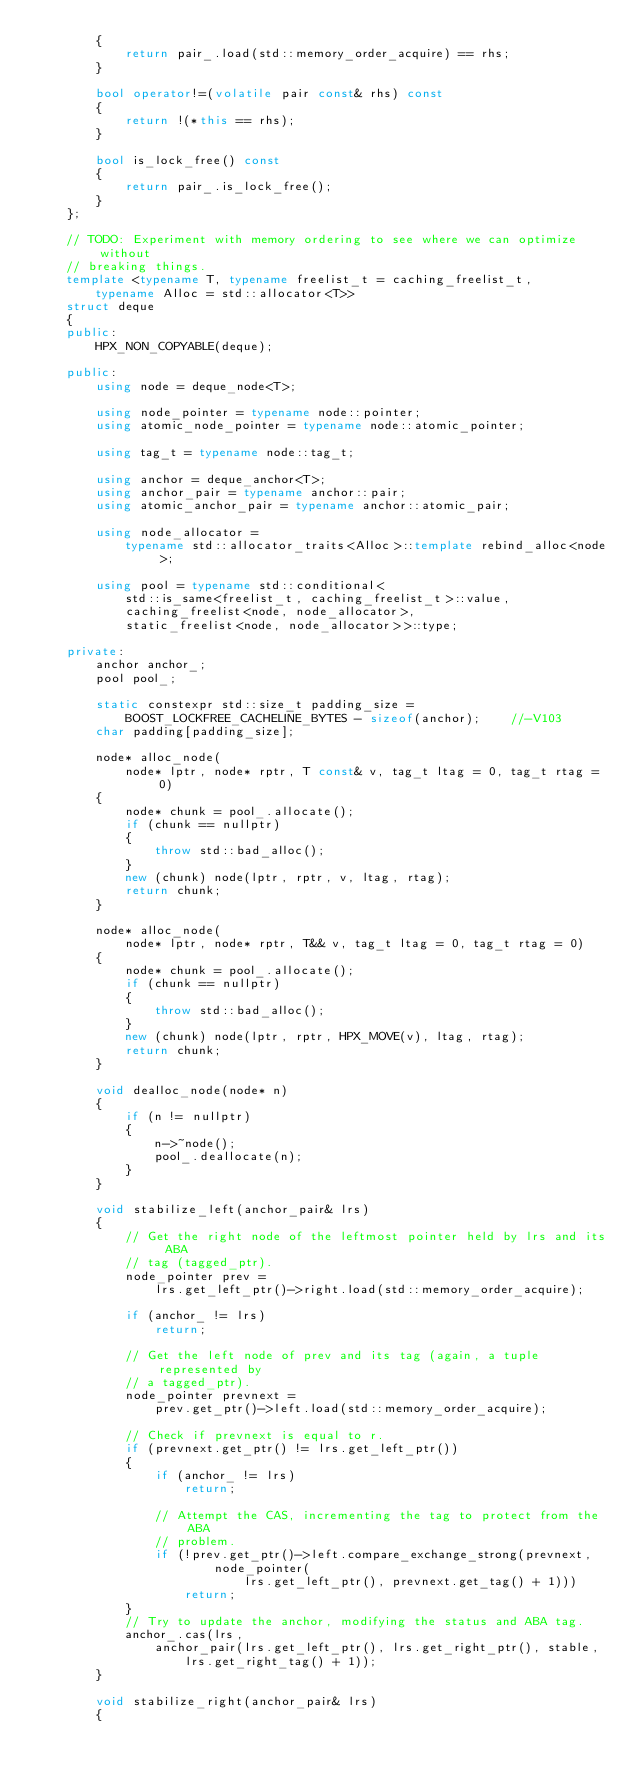Convert code to text. <code><loc_0><loc_0><loc_500><loc_500><_C++_>        {
            return pair_.load(std::memory_order_acquire) == rhs;
        }

        bool operator!=(volatile pair const& rhs) const
        {
            return !(*this == rhs);
        }

        bool is_lock_free() const
        {
            return pair_.is_lock_free();
        }
    };

    // TODO: Experiment with memory ordering to see where we can optimize without
    // breaking things.
    template <typename T, typename freelist_t = caching_freelist_t,
        typename Alloc = std::allocator<T>>
    struct deque
    {
    public:
        HPX_NON_COPYABLE(deque);

    public:
        using node = deque_node<T>;

        using node_pointer = typename node::pointer;
        using atomic_node_pointer = typename node::atomic_pointer;

        using tag_t = typename node::tag_t;

        using anchor = deque_anchor<T>;
        using anchor_pair = typename anchor::pair;
        using atomic_anchor_pair = typename anchor::atomic_pair;

        using node_allocator =
            typename std::allocator_traits<Alloc>::template rebind_alloc<node>;

        using pool = typename std::conditional<
            std::is_same<freelist_t, caching_freelist_t>::value,
            caching_freelist<node, node_allocator>,
            static_freelist<node, node_allocator>>::type;

    private:
        anchor anchor_;
        pool pool_;

        static constexpr std::size_t padding_size =
            BOOST_LOCKFREE_CACHELINE_BYTES - sizeof(anchor);    //-V103
        char padding[padding_size];

        node* alloc_node(
            node* lptr, node* rptr, T const& v, tag_t ltag = 0, tag_t rtag = 0)
        {
            node* chunk = pool_.allocate();
            if (chunk == nullptr)
            {
                throw std::bad_alloc();
            }
            new (chunk) node(lptr, rptr, v, ltag, rtag);
            return chunk;
        }

        node* alloc_node(
            node* lptr, node* rptr, T&& v, tag_t ltag = 0, tag_t rtag = 0)
        {
            node* chunk = pool_.allocate();
            if (chunk == nullptr)
            {
                throw std::bad_alloc();
            }
            new (chunk) node(lptr, rptr, HPX_MOVE(v), ltag, rtag);
            return chunk;
        }

        void dealloc_node(node* n)
        {
            if (n != nullptr)
            {
                n->~node();
                pool_.deallocate(n);
            }
        }

        void stabilize_left(anchor_pair& lrs)
        {
            // Get the right node of the leftmost pointer held by lrs and its ABA
            // tag (tagged_ptr).
            node_pointer prev =
                lrs.get_left_ptr()->right.load(std::memory_order_acquire);

            if (anchor_ != lrs)
                return;

            // Get the left node of prev and its tag (again, a tuple represented by
            // a tagged_ptr).
            node_pointer prevnext =
                prev.get_ptr()->left.load(std::memory_order_acquire);

            // Check if prevnext is equal to r.
            if (prevnext.get_ptr() != lrs.get_left_ptr())
            {
                if (anchor_ != lrs)
                    return;

                // Attempt the CAS, incrementing the tag to protect from the ABA
                // problem.
                if (!prev.get_ptr()->left.compare_exchange_strong(prevnext,
                        node_pointer(
                            lrs.get_left_ptr(), prevnext.get_tag() + 1)))
                    return;
            }
            // Try to update the anchor, modifying the status and ABA tag.
            anchor_.cas(lrs,
                anchor_pair(lrs.get_left_ptr(), lrs.get_right_ptr(), stable,
                    lrs.get_right_tag() + 1));
        }

        void stabilize_right(anchor_pair& lrs)
        {</code> 